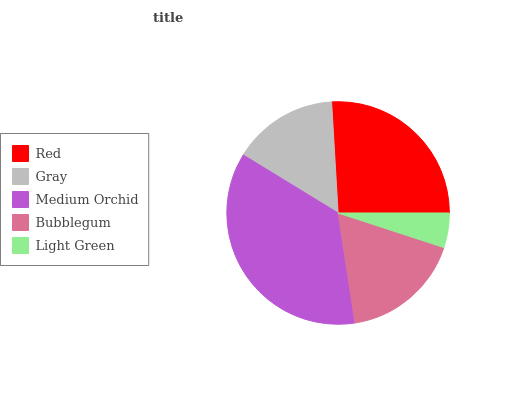Is Light Green the minimum?
Answer yes or no. Yes. Is Medium Orchid the maximum?
Answer yes or no. Yes. Is Gray the minimum?
Answer yes or no. No. Is Gray the maximum?
Answer yes or no. No. Is Red greater than Gray?
Answer yes or no. Yes. Is Gray less than Red?
Answer yes or no. Yes. Is Gray greater than Red?
Answer yes or no. No. Is Red less than Gray?
Answer yes or no. No. Is Bubblegum the high median?
Answer yes or no. Yes. Is Bubblegum the low median?
Answer yes or no. Yes. Is Gray the high median?
Answer yes or no. No. Is Red the low median?
Answer yes or no. No. 